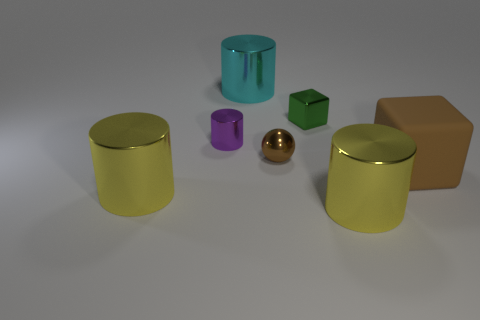Which objects seem to have similar textures? The textures look quite uniform across the objects, giving them a synthetic, perhaps plastic-like feel, but if we look closely, the golden sphere and the teal cylinder appear to have slightly more reflective surfaces compared to the others. 